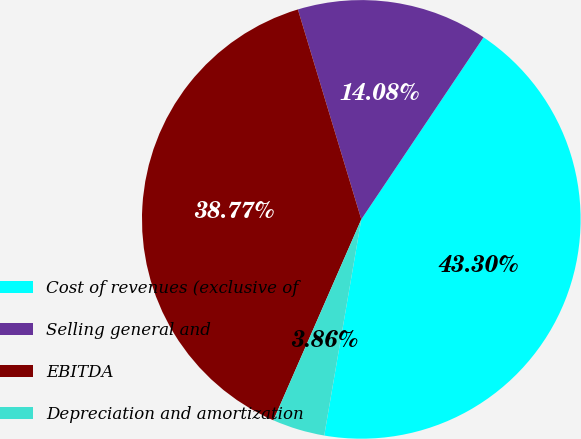Convert chart to OTSL. <chart><loc_0><loc_0><loc_500><loc_500><pie_chart><fcel>Cost of revenues (exclusive of<fcel>Selling general and<fcel>EBITDA<fcel>Depreciation and amortization<nl><fcel>43.3%<fcel>14.08%<fcel>38.77%<fcel>3.86%<nl></chart> 